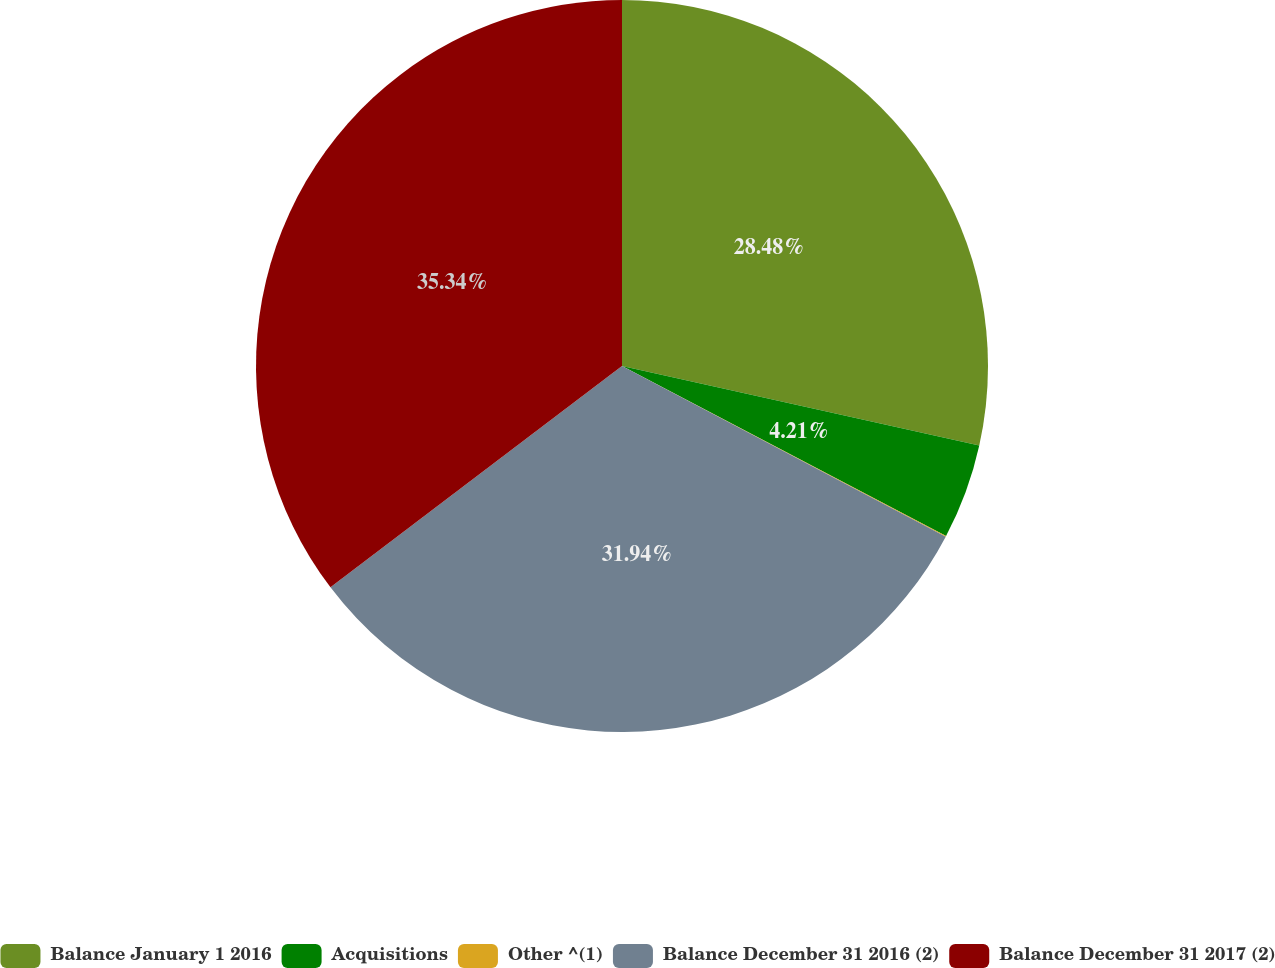Convert chart to OTSL. <chart><loc_0><loc_0><loc_500><loc_500><pie_chart><fcel>Balance January 1 2016<fcel>Acquisitions<fcel>Other ^(1)<fcel>Balance December 31 2016 (2)<fcel>Balance December 31 2017 (2)<nl><fcel>28.48%<fcel>4.21%<fcel>0.03%<fcel>31.94%<fcel>35.33%<nl></chart> 